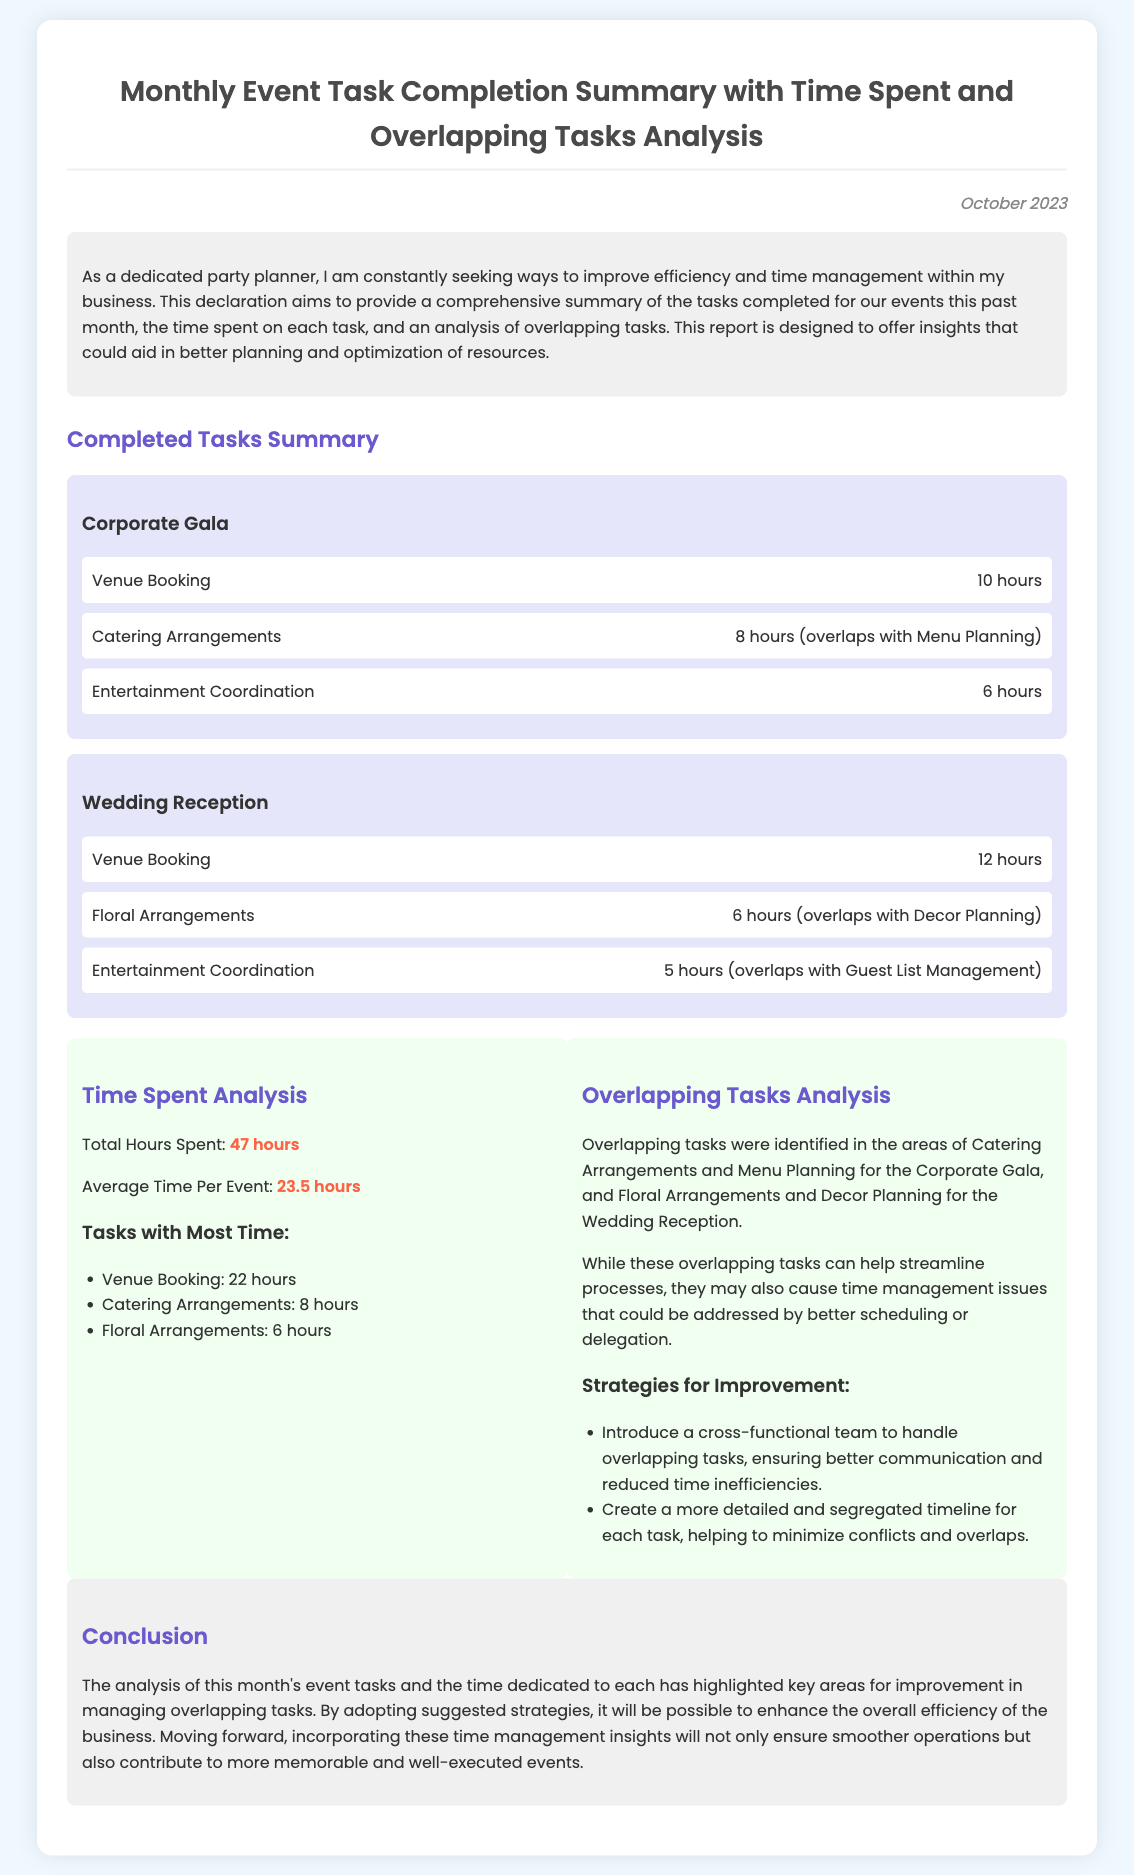What is the total hours spent on tasks? The total hours spent is explicitly mentioned in the analysis section of the document.
Answer: 47 hours What event had the most tasks listed? The document provides a summary of completed tasks for each event, allowing for comparison.
Answer: Corporate Gala How many hours were spent on Venue Booking for the Wedding Reception? The document specifies the hours for Venue Booking under the Wedding Reception section.
Answer: 12 hours Which task overlaps with Menu Planning? The document notes which tasks overlap in the analysis section, particularly regarding the Corporate Gala.
Answer: Catering Arrangements What is the average time spent per event? The average time is calculated from the total hours and the number of events, as stated in the analysis section.
Answer: 23.5 hours What color highlights the most time-consuming tasks? The document uses specific colors to emphasize certain information, including task duration.
Answer: Red How many strategies for improvement are suggested? The document lists strategies under Overlapping Tasks Analysis, which indicates the total number of strategies.
Answer: 2 strategies What is the conclusion about managing overlapping tasks? The conclusion summarizes the findings and insights regarding overlapping tasks, specifically improvements for efficiency.
Answer: Enhance overall efficiency 